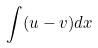Convert formula to latex. <formula><loc_0><loc_0><loc_500><loc_500>\int ( u - v ) d x</formula> 